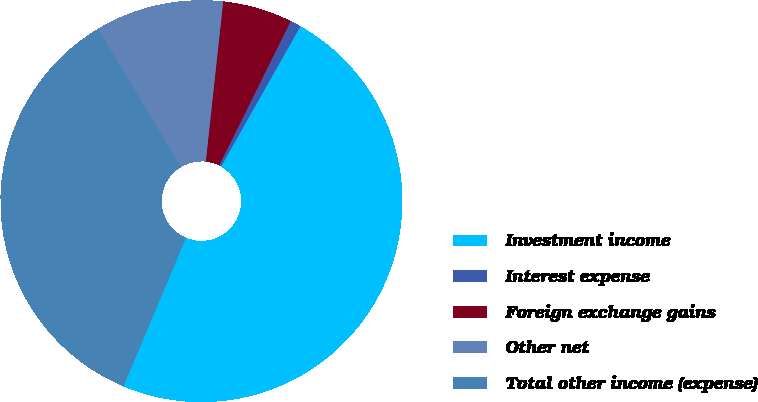Convert chart. <chart><loc_0><loc_0><loc_500><loc_500><pie_chart><fcel>Investment income<fcel>Interest expense<fcel>Foreign exchange gains<fcel>Other net<fcel>Total other income (expense)<nl><fcel>48.16%<fcel>0.87%<fcel>5.6%<fcel>10.33%<fcel>35.05%<nl></chart> 